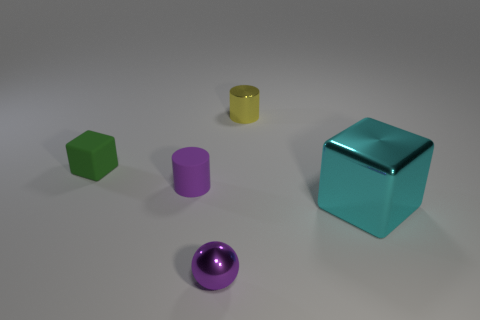Which object seems out of place in this arrangement, based on its size? Based on the size, the large turquoise cube seems to dominate the scene and feels somewhat out of place compared to the smaller objects.  Could you guess the purpose of this arrangement? The purpose is not immediately clear, but it might be an artistic display, a simplistic 3D rendering test, or a visual experiment with shapes and colors. 